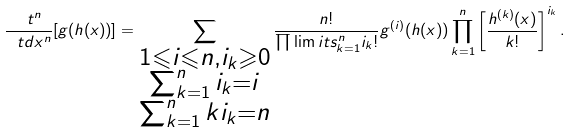<formula> <loc_0><loc_0><loc_500><loc_500>\frac { \ t ^ { n } } { \ t d x ^ { n } } [ g ( h ( x ) ) ] = \sum _ { \substack { 1 \leqslant i \leqslant n , i _ { k } \geqslant 0 \\ \sum _ { k = 1 } ^ { n } i _ { k } = i \\ \sum _ { k = 1 } ^ { n } k i _ { k } = n } } \frac { n ! } { \prod \lim i t s _ { k = 1 } ^ { n } i _ { k } ! } g ^ { ( i ) } ( h ( x ) ) \prod _ { k = 1 } ^ { n } \left [ \frac { h ^ { ( k ) } ( x ) } { k ! } \right ] ^ { i _ { k } } .</formula> 